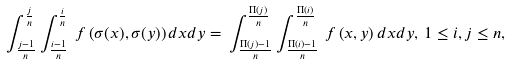Convert formula to latex. <formula><loc_0><loc_0><loc_500><loc_500>\int _ { \frac { j - 1 } { n } } ^ { \frac { j } { n } } \int _ { \frac { i - 1 } { n } } ^ { \frac { i } { n } } \, f \left ( \sigma ( x ) , \sigma ( y ) \right ) d x d y = \, \int _ { \frac { \Pi ( j ) - 1 } { n } } ^ { \frac { \Pi ( j ) } { n } } \int _ { \frac { \Pi ( i ) - 1 } { n } } ^ { \frac { \Pi ( i ) } { n } } \, f \left ( x , y \right ) d x d y , \, 1 \leq i , j \leq n ,</formula> 